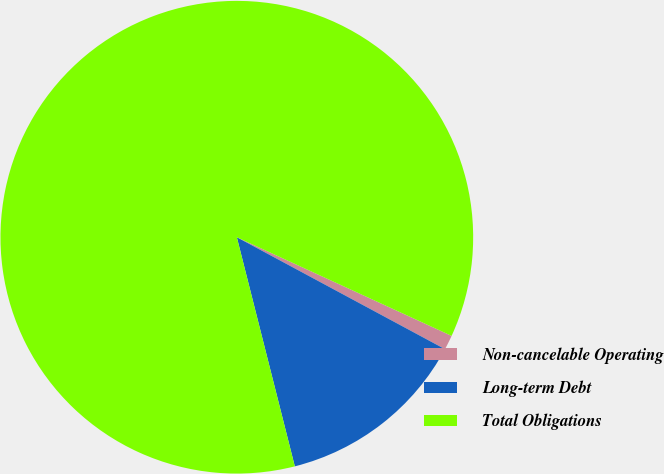Convert chart. <chart><loc_0><loc_0><loc_500><loc_500><pie_chart><fcel>Non-cancelable Operating<fcel>Long-term Debt<fcel>Total Obligations<nl><fcel>1.0%<fcel>13.2%<fcel>85.79%<nl></chart> 